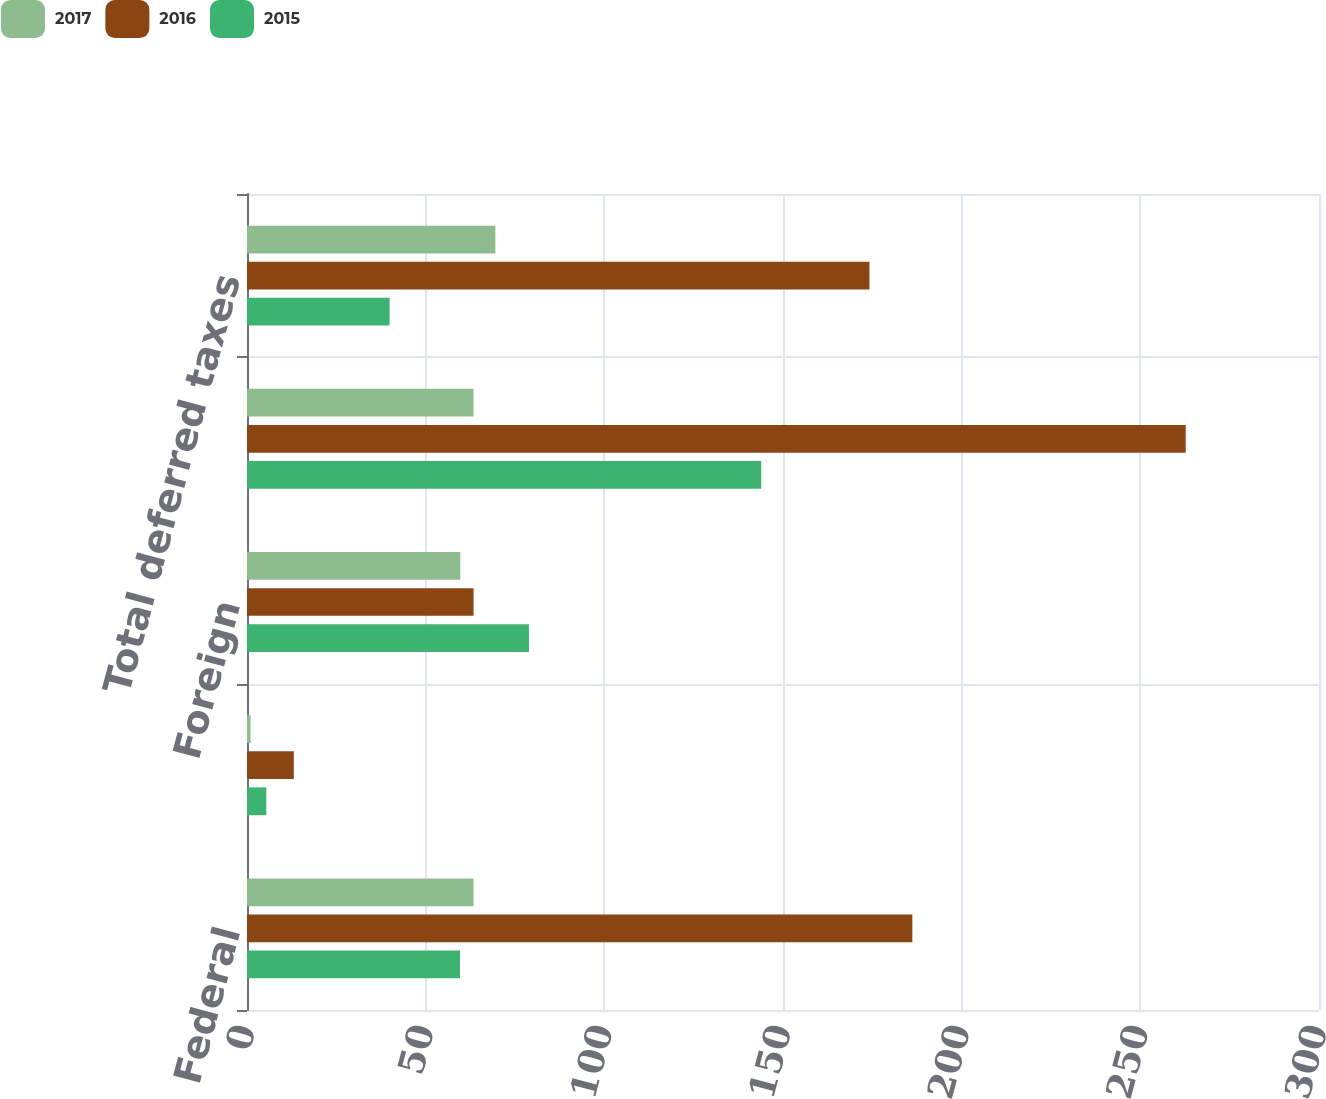Convert chart. <chart><loc_0><loc_0><loc_500><loc_500><stacked_bar_chart><ecel><fcel>Federal<fcel>State and local<fcel>Foreign<fcel>Total current taxes<fcel>Total deferred taxes<nl><fcel>2017<fcel>63.4<fcel>1<fcel>59.7<fcel>63.4<fcel>69.5<nl><fcel>2016<fcel>186.2<fcel>13.1<fcel>63.4<fcel>262.7<fcel>174.2<nl><fcel>2015<fcel>59.6<fcel>5.4<fcel>78.9<fcel>143.9<fcel>39.9<nl></chart> 